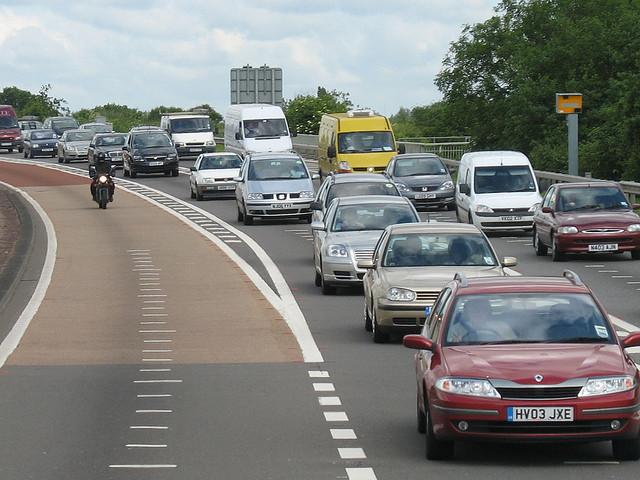Is this photo in Europe?
Short answer required. Yes. How many motorcycles do you see?
Be succinct. 1. Is the motorcycle doing anything illegal?
Concise answer only. No. 